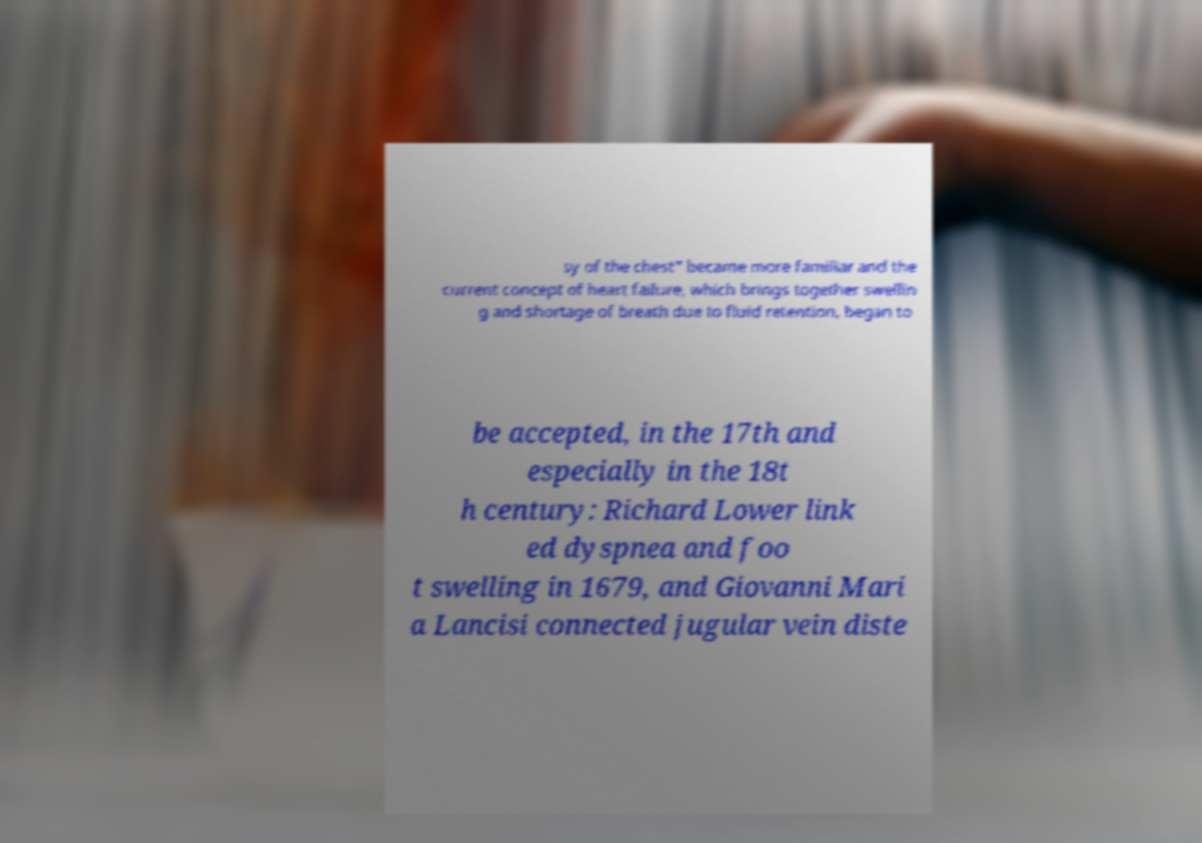I need the written content from this picture converted into text. Can you do that? sy of the chest" became more familiar and the current concept of heart failure, which brings together swellin g and shortage of breath due to fluid retention, began to be accepted, in the 17th and especially in the 18t h century: Richard Lower link ed dyspnea and foo t swelling in 1679, and Giovanni Mari a Lancisi connected jugular vein diste 